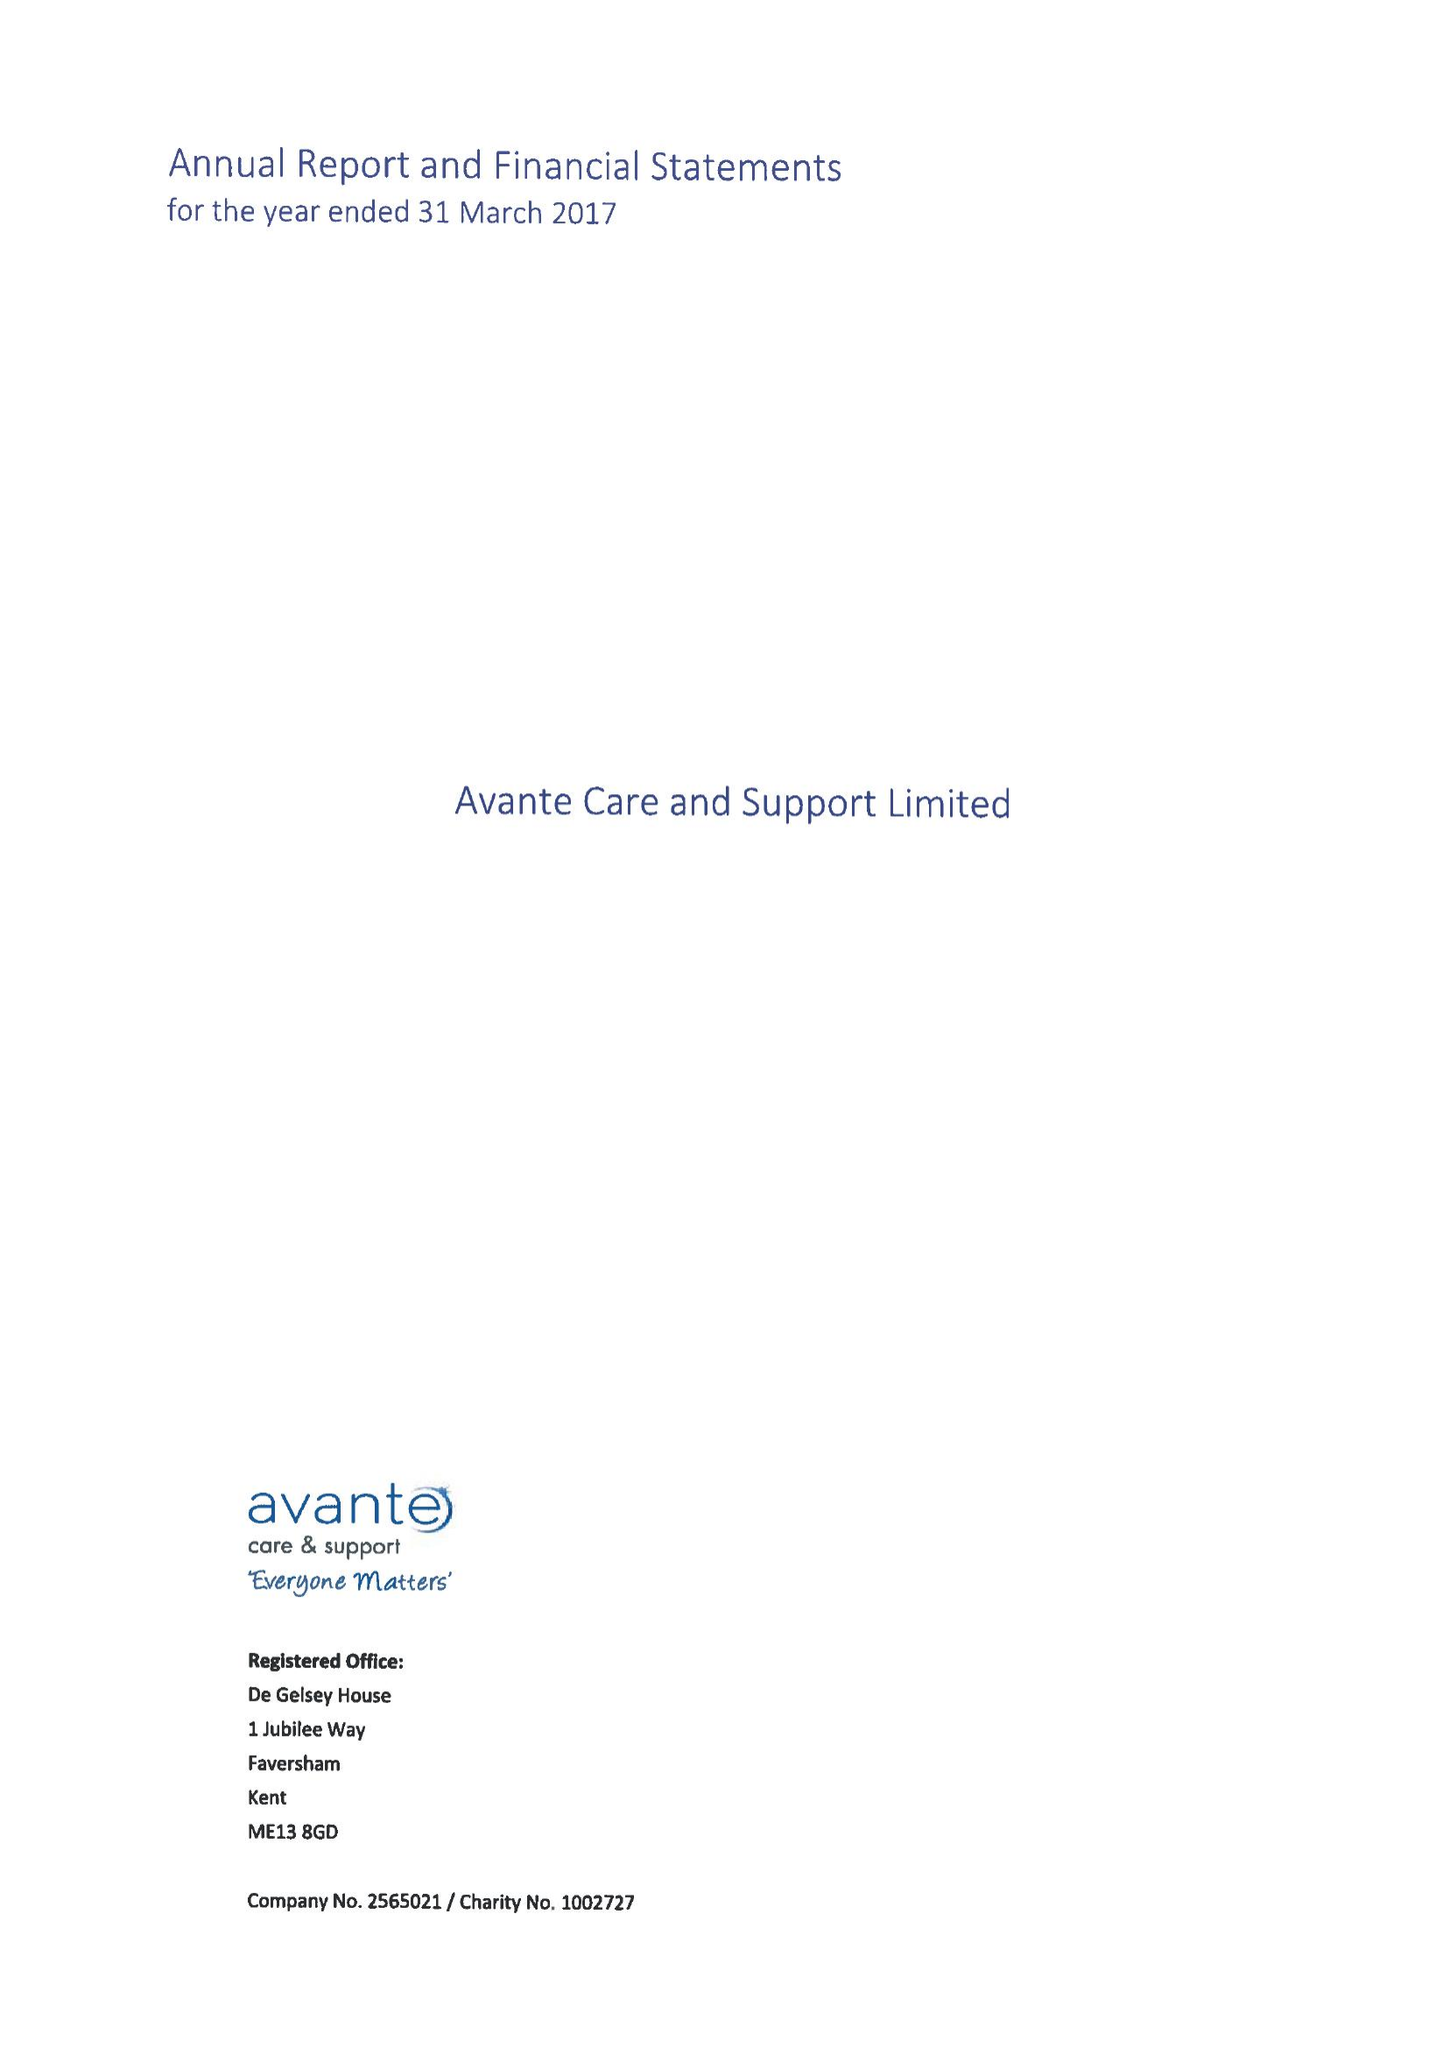What is the value for the address__street_line?
Answer the question using a single word or phrase. 1 JUBILEE WAY 